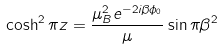Convert formula to latex. <formula><loc_0><loc_0><loc_500><loc_500>\cosh ^ { 2 } \pi z = \frac { \mu _ { B } ^ { 2 } e ^ { - 2 i \beta \phi _ { 0 } } } { \mu } \sin \pi \beta ^ { 2 }</formula> 